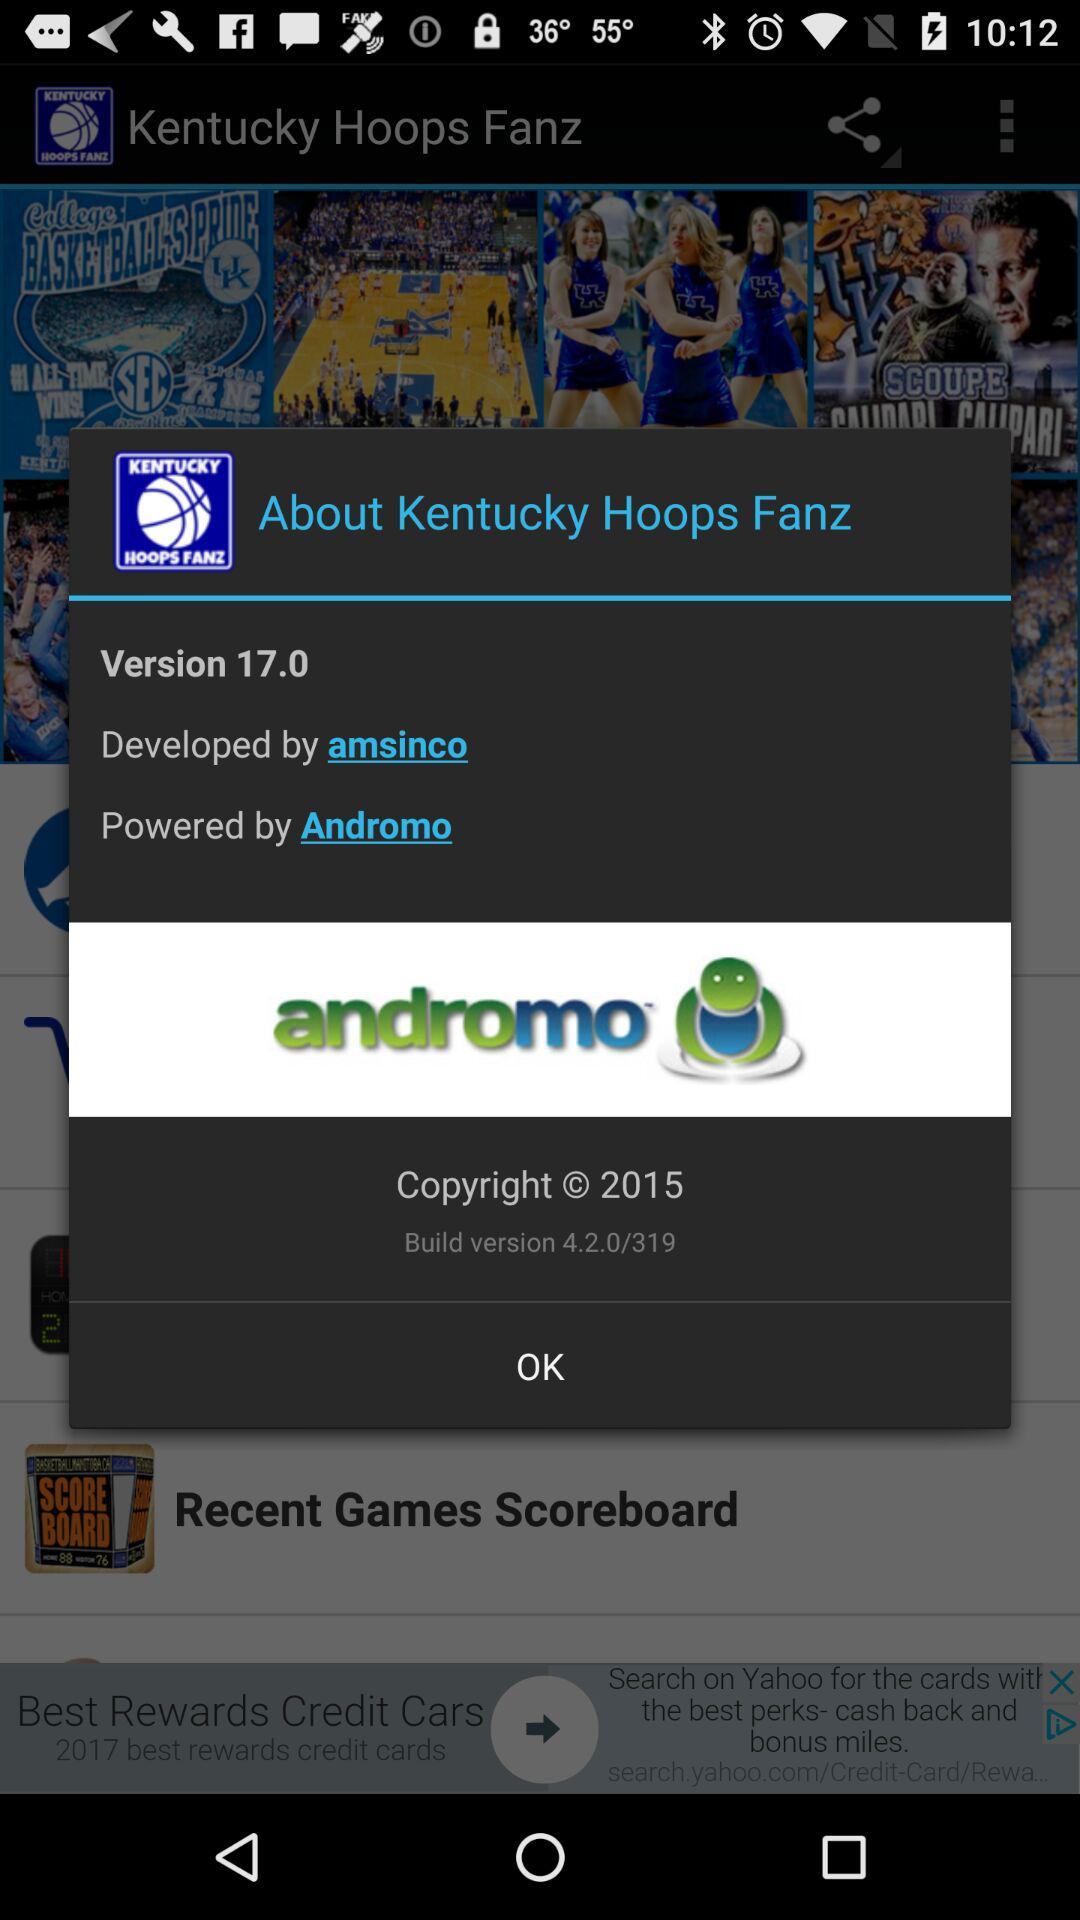Which company has developed the "Kentucky Hoops Fanz"? The company that has developed the "Kentucky Hoops Fanz" is "amsinco". 